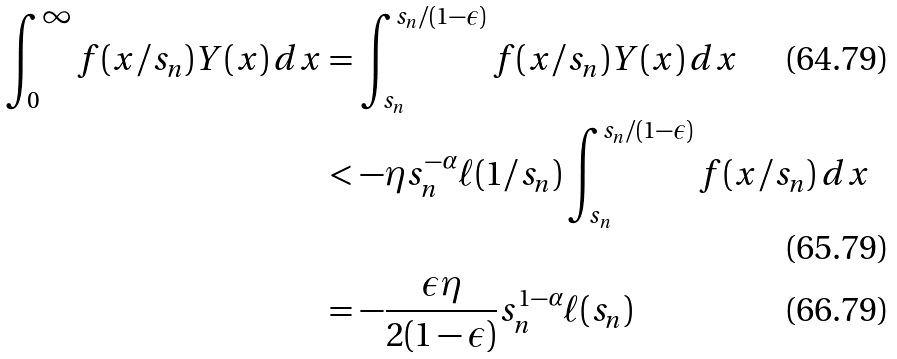Convert formula to latex. <formula><loc_0><loc_0><loc_500><loc_500>\int _ { 0 } ^ { \infty } f ( x / s _ { n } ) Y ( x ) \, d x & = \int _ { s _ { n } } ^ { s _ { n } / ( 1 - \epsilon ) } f ( x / s _ { n } ) Y ( x ) \, d x \\ & < - \eta s _ { n } ^ { - \alpha } \ell ( 1 / s _ { n } ) \int _ { s _ { n } } ^ { s _ { n } / ( 1 - \epsilon ) } f ( x / s _ { n } ) \, d x \\ & = - \frac { \epsilon \eta } { 2 ( 1 - \epsilon ) } s _ { n } ^ { 1 - \alpha } \ell ( s _ { n } )</formula> 